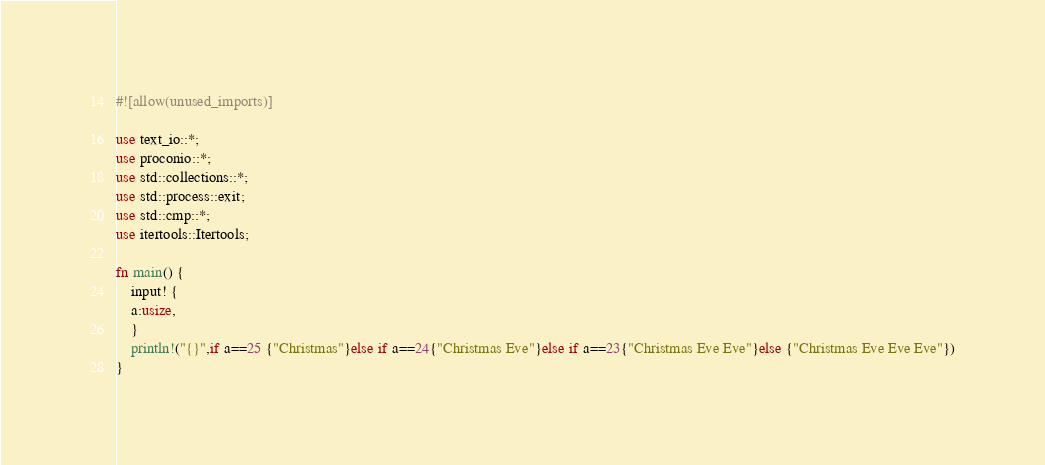Convert code to text. <code><loc_0><loc_0><loc_500><loc_500><_Rust_>#![allow(unused_imports)]

use text_io::*;
use proconio::*;
use std::collections::*;
use std::process::exit;
use std::cmp::*;
use itertools::Itertools;

fn main() {
    input! {
    a:usize,
    }
    println!("{}",if a==25 {"Christmas"}else if a==24{"Christmas Eve"}else if a==23{"Christmas Eve Eve"}else {"Christmas Eve Eve Eve"})
}</code> 